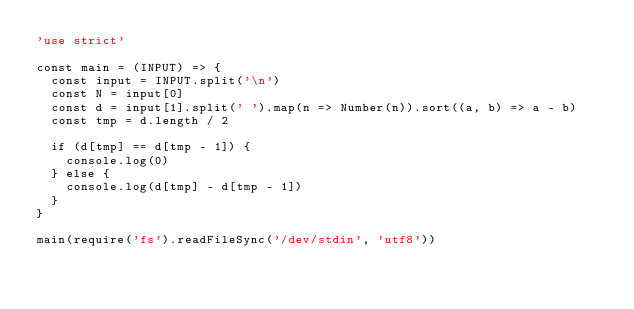<code> <loc_0><loc_0><loc_500><loc_500><_JavaScript_>'use strict'

const main = (INPUT) => {
  const input = INPUT.split('\n')
  const N = input[0]
  const d = input[1].split(' ').map(n => Number(n)).sort((a, b) => a - b)
  const tmp = d.length / 2

  if (d[tmp] == d[tmp - 1]) {
    console.log(0)
  } else {
    console.log(d[tmp] - d[tmp - 1])
  }
}

main(require('fs').readFileSync('/dev/stdin', 'utf8'))
</code> 